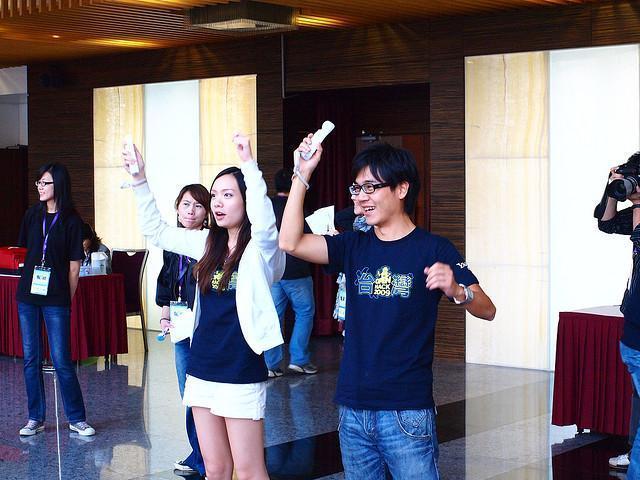How many people can you see?
Give a very brief answer. 6. How many keyboards are there?
Give a very brief answer. 0. 